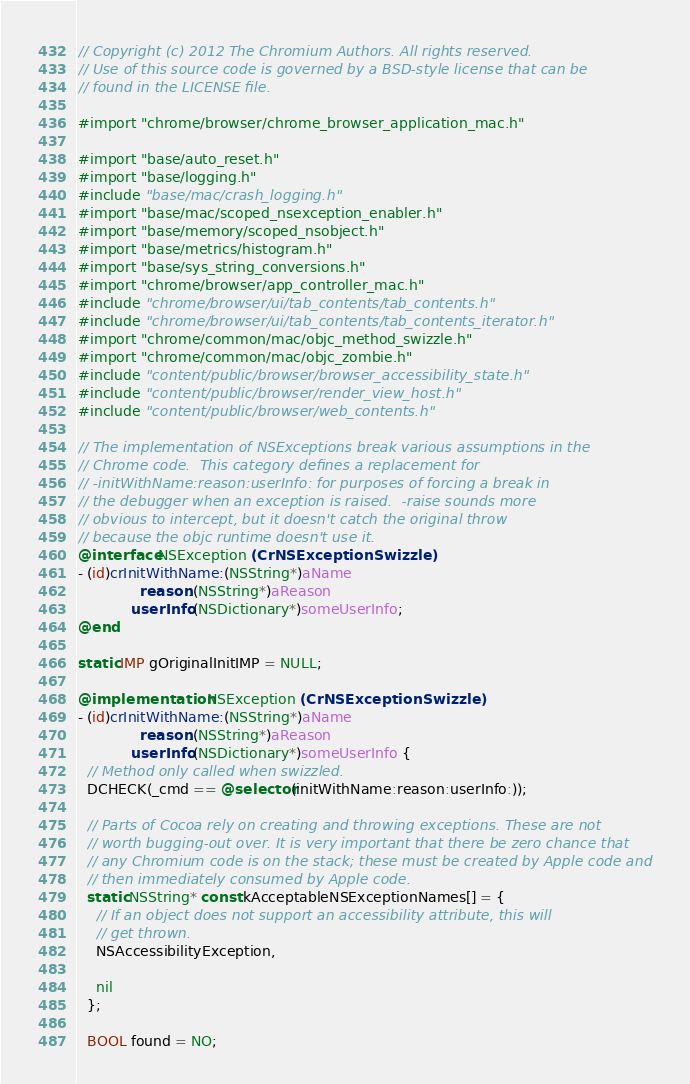<code> <loc_0><loc_0><loc_500><loc_500><_ObjectiveC_>// Copyright (c) 2012 The Chromium Authors. All rights reserved.
// Use of this source code is governed by a BSD-style license that can be
// found in the LICENSE file.

#import "chrome/browser/chrome_browser_application_mac.h"

#import "base/auto_reset.h"
#import "base/logging.h"
#include "base/mac/crash_logging.h"
#import "base/mac/scoped_nsexception_enabler.h"
#import "base/memory/scoped_nsobject.h"
#import "base/metrics/histogram.h"
#import "base/sys_string_conversions.h"
#import "chrome/browser/app_controller_mac.h"
#include "chrome/browser/ui/tab_contents/tab_contents.h"
#include "chrome/browser/ui/tab_contents/tab_contents_iterator.h"
#import "chrome/common/mac/objc_method_swizzle.h"
#import "chrome/common/mac/objc_zombie.h"
#include "content/public/browser/browser_accessibility_state.h"
#include "content/public/browser/render_view_host.h"
#include "content/public/browser/web_contents.h"

// The implementation of NSExceptions break various assumptions in the
// Chrome code.  This category defines a replacement for
// -initWithName:reason:userInfo: for purposes of forcing a break in
// the debugger when an exception is raised.  -raise sounds more
// obvious to intercept, but it doesn't catch the original throw
// because the objc runtime doesn't use it.
@interface NSException (CrNSExceptionSwizzle)
- (id)crInitWithName:(NSString*)aName
              reason:(NSString*)aReason
            userInfo:(NSDictionary*)someUserInfo;
@end

static IMP gOriginalInitIMP = NULL;

@implementation NSException (CrNSExceptionSwizzle)
- (id)crInitWithName:(NSString*)aName
              reason:(NSString*)aReason
            userInfo:(NSDictionary*)someUserInfo {
  // Method only called when swizzled.
  DCHECK(_cmd == @selector(initWithName:reason:userInfo:));

  // Parts of Cocoa rely on creating and throwing exceptions. These are not
  // worth bugging-out over. It is very important that there be zero chance that
  // any Chromium code is on the stack; these must be created by Apple code and
  // then immediately consumed by Apple code.
  static NSString* const kAcceptableNSExceptionNames[] = {
    // If an object does not support an accessibility attribute, this will
    // get thrown.
    NSAccessibilityException,

    nil
  };

  BOOL found = NO;</code> 